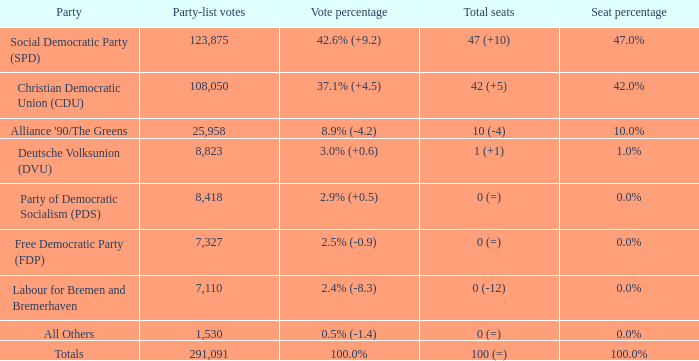What is the seat percentage when vote percentage is 2.4% (-8.3)? 0.0%. 